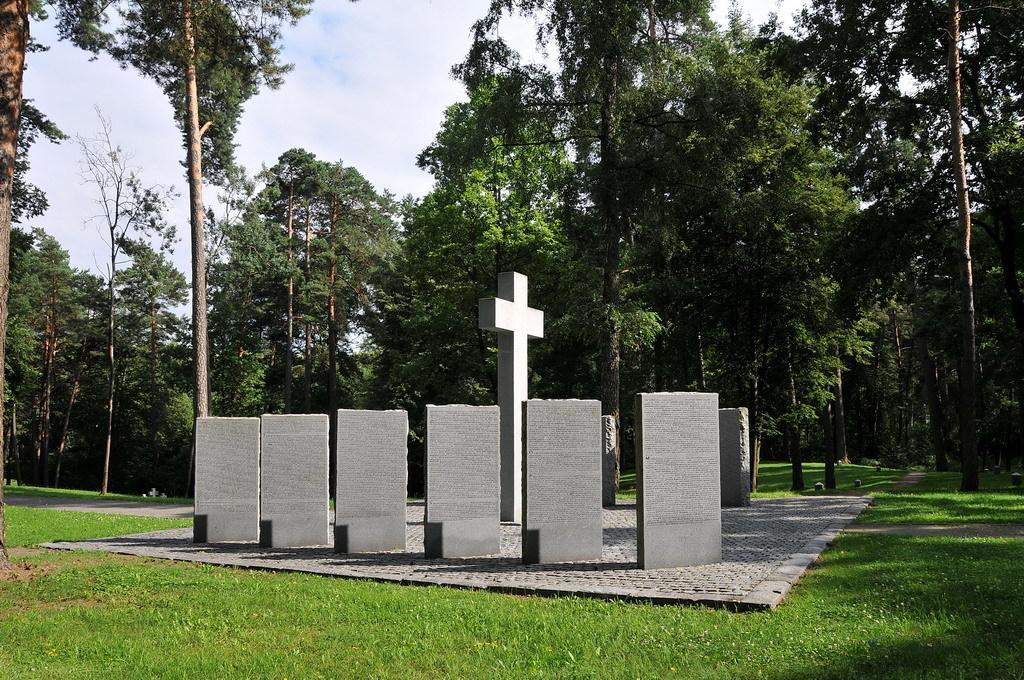Please provide a concise description of this image. In this image, we can see some stones and there is a holy cross symbol, there's grass on the ground, we can see some trees, at the top there is a sky. 